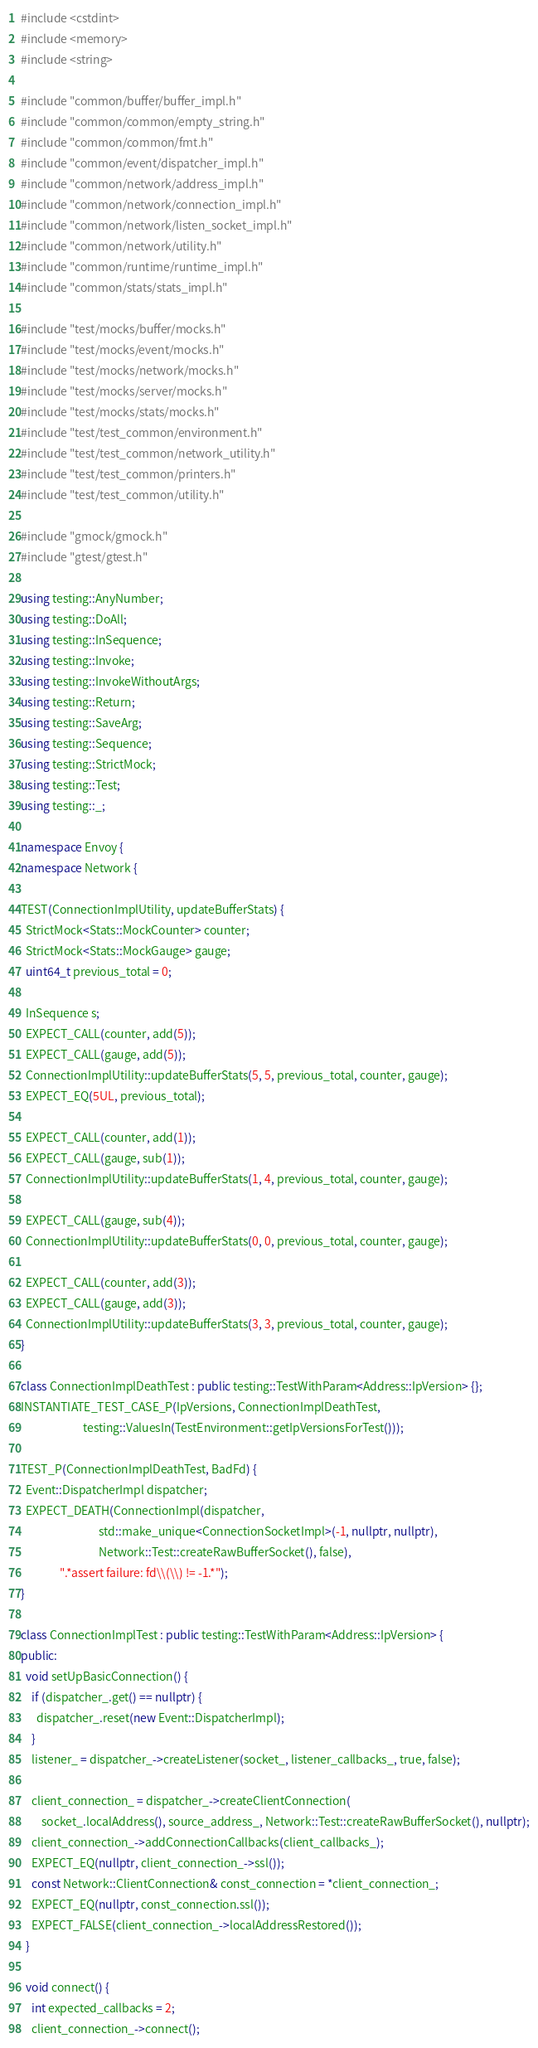Convert code to text. <code><loc_0><loc_0><loc_500><loc_500><_C++_>#include <cstdint>
#include <memory>
#include <string>

#include "common/buffer/buffer_impl.h"
#include "common/common/empty_string.h"
#include "common/common/fmt.h"
#include "common/event/dispatcher_impl.h"
#include "common/network/address_impl.h"
#include "common/network/connection_impl.h"
#include "common/network/listen_socket_impl.h"
#include "common/network/utility.h"
#include "common/runtime/runtime_impl.h"
#include "common/stats/stats_impl.h"

#include "test/mocks/buffer/mocks.h"
#include "test/mocks/event/mocks.h"
#include "test/mocks/network/mocks.h"
#include "test/mocks/server/mocks.h"
#include "test/mocks/stats/mocks.h"
#include "test/test_common/environment.h"
#include "test/test_common/network_utility.h"
#include "test/test_common/printers.h"
#include "test/test_common/utility.h"

#include "gmock/gmock.h"
#include "gtest/gtest.h"

using testing::AnyNumber;
using testing::DoAll;
using testing::InSequence;
using testing::Invoke;
using testing::InvokeWithoutArgs;
using testing::Return;
using testing::SaveArg;
using testing::Sequence;
using testing::StrictMock;
using testing::Test;
using testing::_;

namespace Envoy {
namespace Network {

TEST(ConnectionImplUtility, updateBufferStats) {
  StrictMock<Stats::MockCounter> counter;
  StrictMock<Stats::MockGauge> gauge;
  uint64_t previous_total = 0;

  InSequence s;
  EXPECT_CALL(counter, add(5));
  EXPECT_CALL(gauge, add(5));
  ConnectionImplUtility::updateBufferStats(5, 5, previous_total, counter, gauge);
  EXPECT_EQ(5UL, previous_total);

  EXPECT_CALL(counter, add(1));
  EXPECT_CALL(gauge, sub(1));
  ConnectionImplUtility::updateBufferStats(1, 4, previous_total, counter, gauge);

  EXPECT_CALL(gauge, sub(4));
  ConnectionImplUtility::updateBufferStats(0, 0, previous_total, counter, gauge);

  EXPECT_CALL(counter, add(3));
  EXPECT_CALL(gauge, add(3));
  ConnectionImplUtility::updateBufferStats(3, 3, previous_total, counter, gauge);
}

class ConnectionImplDeathTest : public testing::TestWithParam<Address::IpVersion> {};
INSTANTIATE_TEST_CASE_P(IpVersions, ConnectionImplDeathTest,
                        testing::ValuesIn(TestEnvironment::getIpVersionsForTest()));

TEST_P(ConnectionImplDeathTest, BadFd) {
  Event::DispatcherImpl dispatcher;
  EXPECT_DEATH(ConnectionImpl(dispatcher,
                              std::make_unique<ConnectionSocketImpl>(-1, nullptr, nullptr),
                              Network::Test::createRawBufferSocket(), false),
               ".*assert failure: fd\\(\\) != -1.*");
}

class ConnectionImplTest : public testing::TestWithParam<Address::IpVersion> {
public:
  void setUpBasicConnection() {
    if (dispatcher_.get() == nullptr) {
      dispatcher_.reset(new Event::DispatcherImpl);
    }
    listener_ = dispatcher_->createListener(socket_, listener_callbacks_, true, false);

    client_connection_ = dispatcher_->createClientConnection(
        socket_.localAddress(), source_address_, Network::Test::createRawBufferSocket(), nullptr);
    client_connection_->addConnectionCallbacks(client_callbacks_);
    EXPECT_EQ(nullptr, client_connection_->ssl());
    const Network::ClientConnection& const_connection = *client_connection_;
    EXPECT_EQ(nullptr, const_connection.ssl());
    EXPECT_FALSE(client_connection_->localAddressRestored());
  }

  void connect() {
    int expected_callbacks = 2;
    client_connection_->connect();</code> 